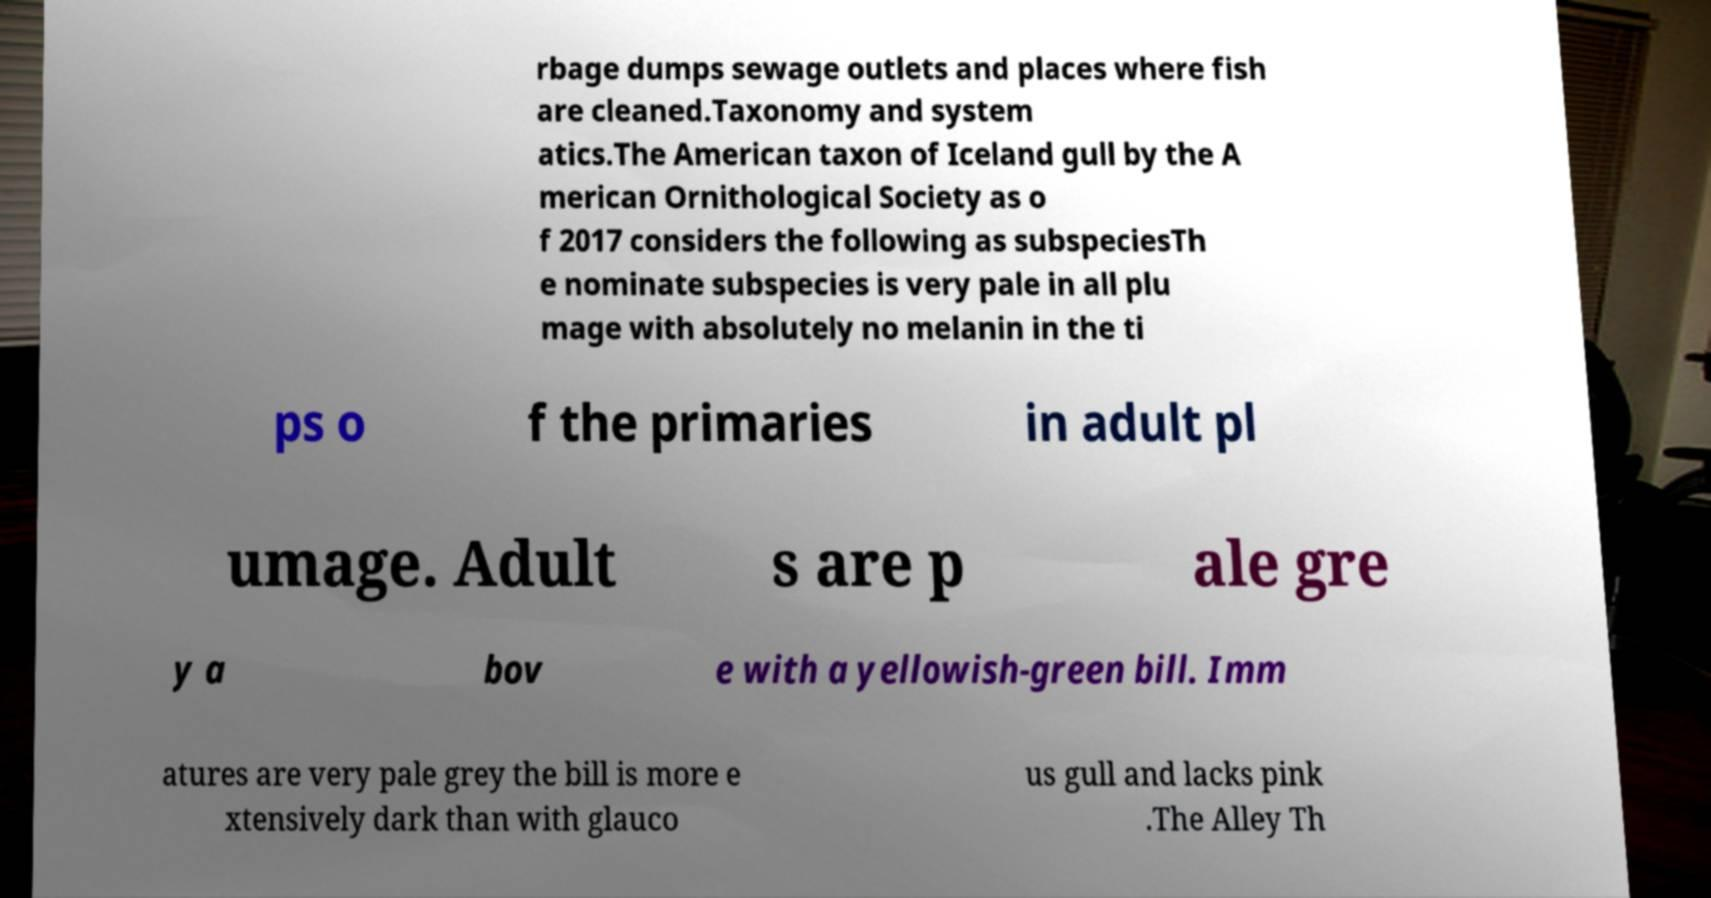Can you accurately transcribe the text from the provided image for me? rbage dumps sewage outlets and places where fish are cleaned.Taxonomy and system atics.The American taxon of Iceland gull by the A merican Ornithological Society as o f 2017 considers the following as subspeciesTh e nominate subspecies is very pale in all plu mage with absolutely no melanin in the ti ps o f the primaries in adult pl umage. Adult s are p ale gre y a bov e with a yellowish-green bill. Imm atures are very pale grey the bill is more e xtensively dark than with glauco us gull and lacks pink .The Alley Th 